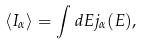<formula> <loc_0><loc_0><loc_500><loc_500>\left \langle I _ { \alpha } \right \rangle = \int d E j _ { \alpha } ( E ) ,</formula> 